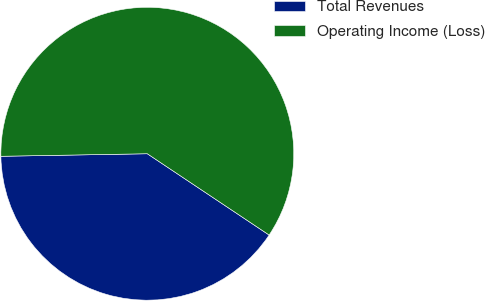Convert chart. <chart><loc_0><loc_0><loc_500><loc_500><pie_chart><fcel>Total Revenues<fcel>Operating Income (Loss)<nl><fcel>40.36%<fcel>59.64%<nl></chart> 